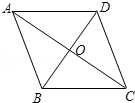In the diamond ABCD, given that AC is 32 units long and BD is 24 units long, what is the side length of the diamond? Choices: A: 16.0 B: 20.0 C: 24.0 D: 40.0 To determine the side length of diamond ABCD, which is a rhombus, we start by noting that its diagonals AC and BD are perpendicular bisectors of one another. With AC measuring 32 units and BD 24 units, each half of AC is 16 units and each half of BD is 12 units. By applying the Pythagorean theorem to one half of the rhombus, we solve for the side length: side = √(16² + 12²) = 20 units. Hence, the correct answer is B: 20.0. 